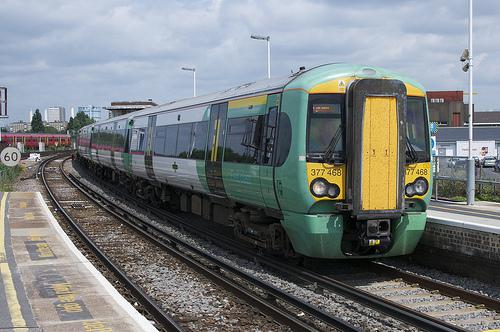Question: what color are the tracks?
Choices:
A. Red.
B. Blue.
C. Black.
D. Gray.
Answer with the letter. Answer: C Question: where are the rocks?
Choices:
A. On the ground.
B. On the track.
C. In a shoe.
D. In dirt.
Answer with the letter. Answer: B 